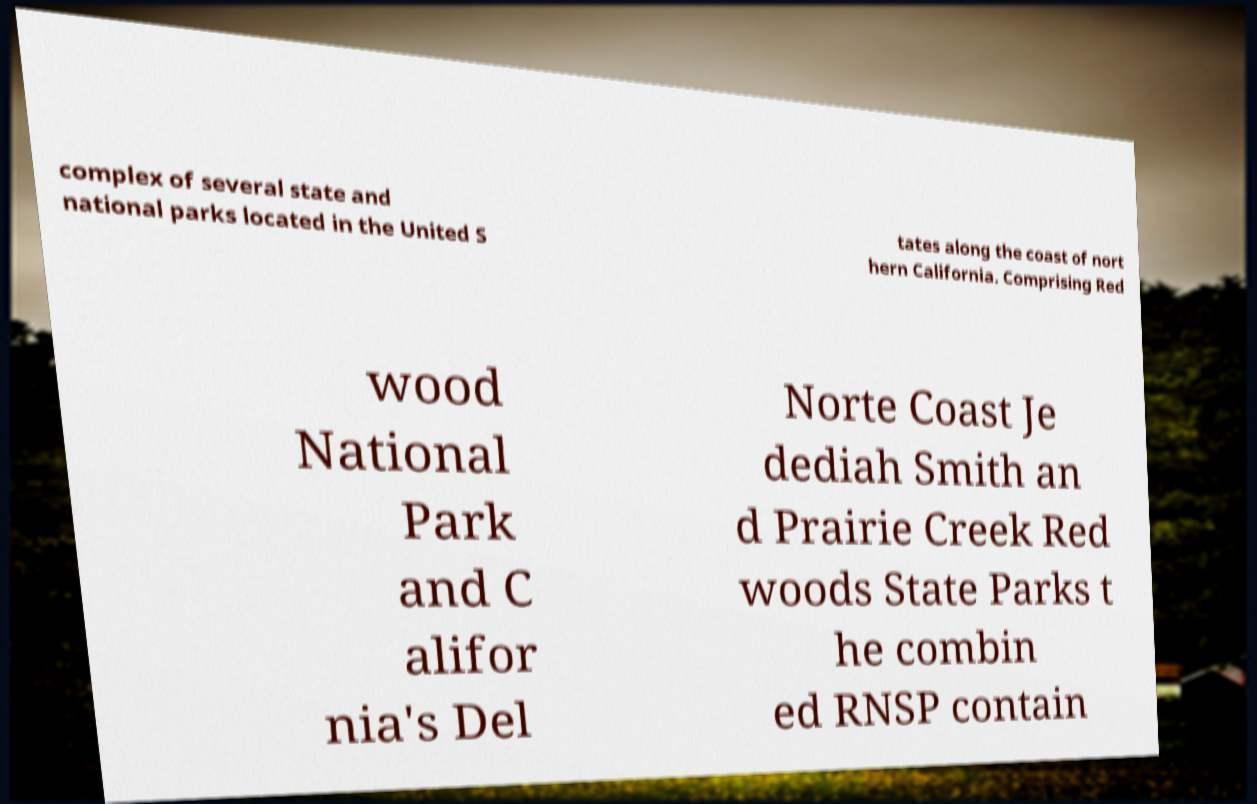Can you accurately transcribe the text from the provided image for me? complex of several state and national parks located in the United S tates along the coast of nort hern California. Comprising Red wood National Park and C alifor nia's Del Norte Coast Je dediah Smith an d Prairie Creek Red woods State Parks t he combin ed RNSP contain 